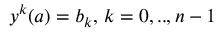Convert formula to latex. <formula><loc_0><loc_0><loc_500><loc_500>y ^ { k } ( a ) = b _ { k } , \, k = 0 , . . , n - 1</formula> 